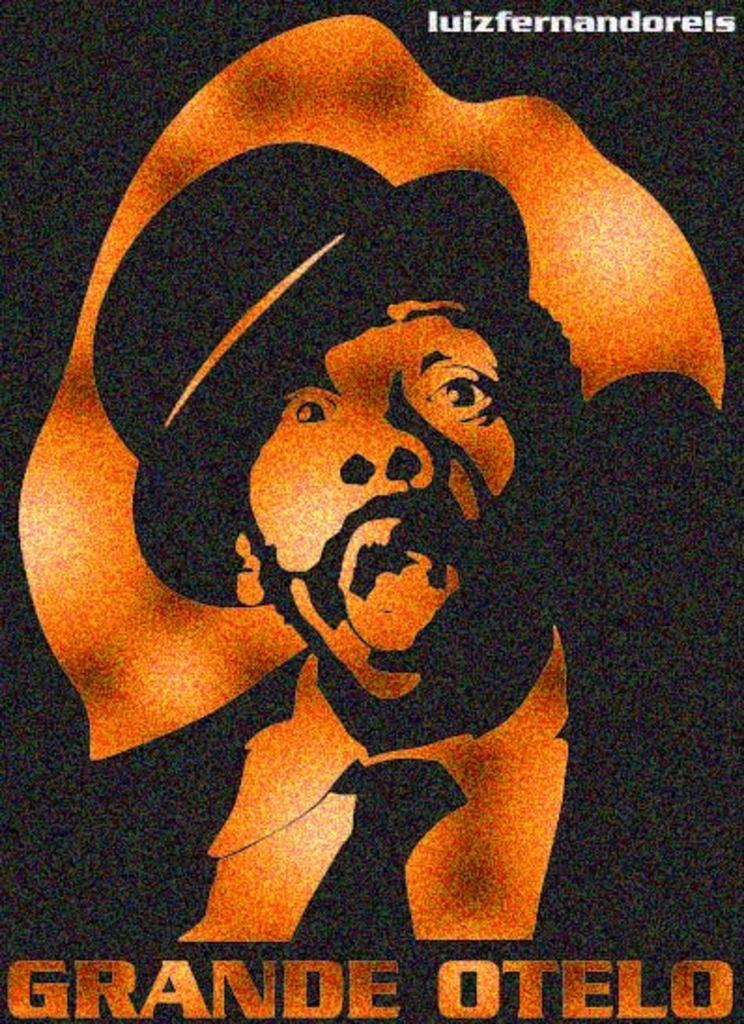<image>
Share a concise interpretation of the image provided. The show being featured on the poster is called Grande Otelo. 